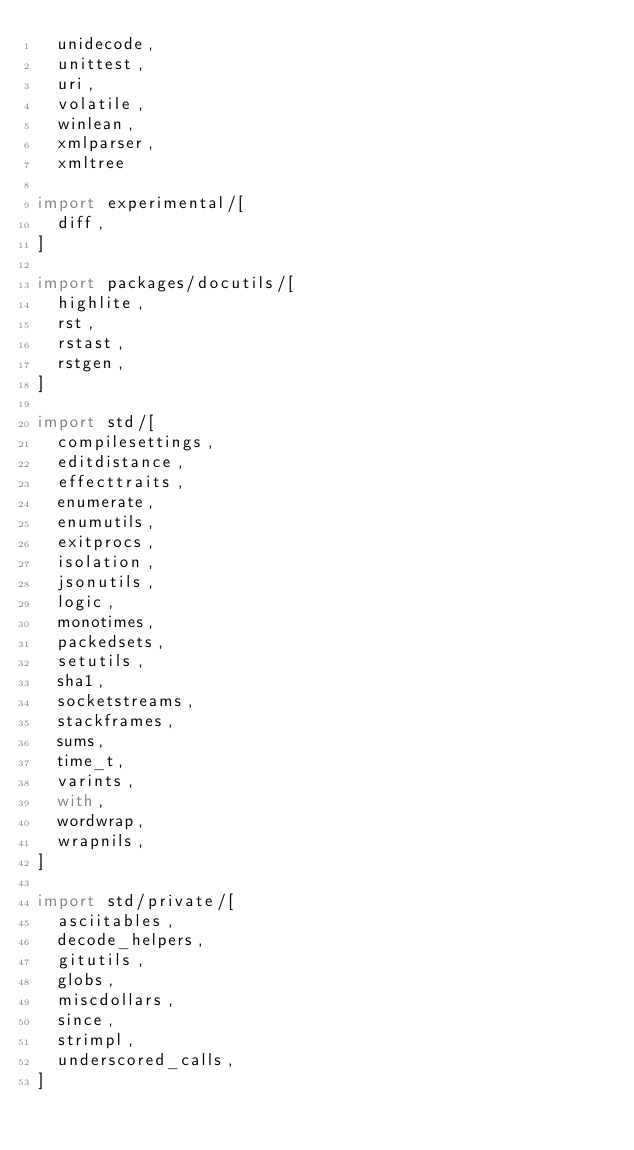<code> <loc_0><loc_0><loc_500><loc_500><_Nim_>  unidecode,
  unittest,
  uri,
  volatile,
  winlean,
  xmlparser,
  xmltree

import experimental/[
  diff,
]

import packages/docutils/[
  highlite,
  rst,
  rstast,
  rstgen,
]

import std/[
  compilesettings,
  editdistance,
  effecttraits,
  enumerate,
  enumutils,
  exitprocs,
  isolation,
  jsonutils,
  logic,
  monotimes,
  packedsets,
  setutils,
  sha1,
  socketstreams,
  stackframes,
  sums,
  time_t,
  varints,
  with,
  wordwrap,
  wrapnils,
]

import std/private/[
  asciitables,
  decode_helpers,
  gitutils,
  globs,
  miscdollars,
  since,
  strimpl,
  underscored_calls,
]
</code> 